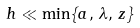<formula> <loc_0><loc_0><loc_500><loc_500>h \ll \min \{ a , \, \lambda , \, z \}</formula> 